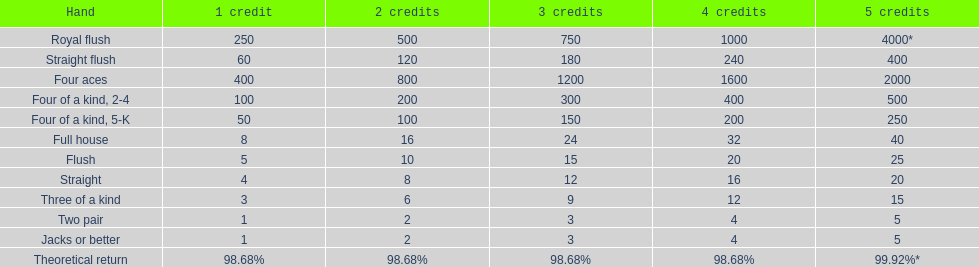Which hand is the top hand in the card game super aces? Royal flush. 